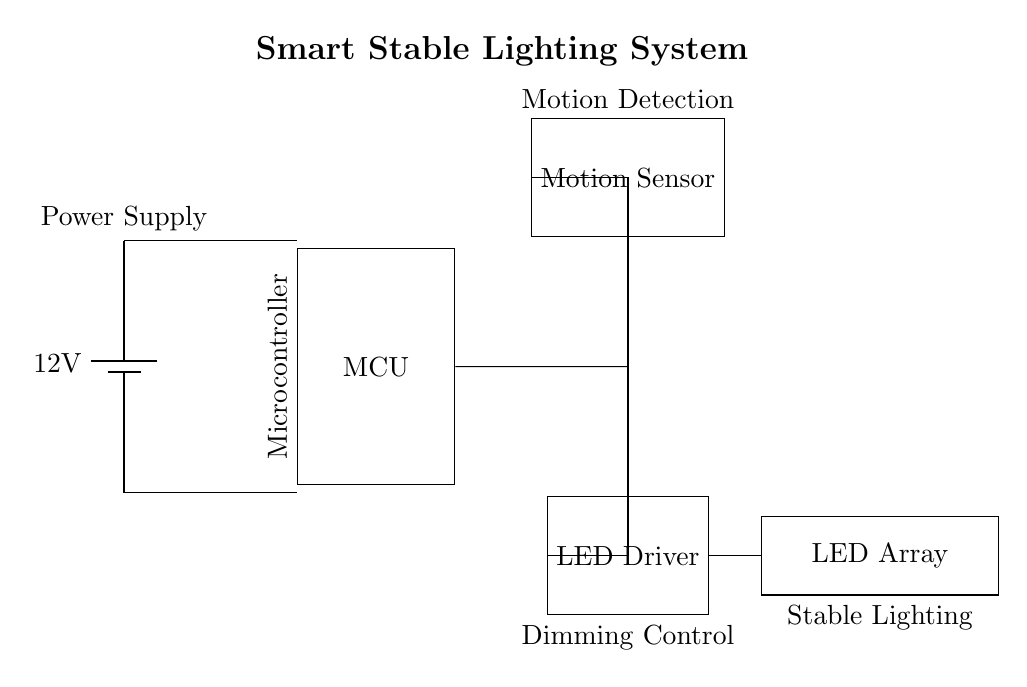What is the voltage of the power supply? The voltage is specified as 12 volts in the circuit. This is the potential difference provided by the battery.
Answer: 12 volts What component is used for motion detection? The component labeled as 'Motion Sensor' is responsible for detecting motion in the circuit diagram.
Answer: Motion Sensor What is the purpose of the LED driver in this circuit? The LED driver controls the brightness of the LED array, allowing for dimming capabilities. Its role is to provide the appropriate voltage and current to the LEDs.
Answer: Dimming control How many main components are shown in the circuit diagram? There are four main components: the power supply, the microcontroller, the motion sensor, and the LED driver. Counting these gives a total of four components.
Answer: Four Which component connects the motion sensor and the LED array? The LED Driver serves as the intermediary between the motion sensor control signals and the LED array, relaying the appropriate current to the lights.
Answer: LED Driver What does the microcontroller manage in this circuit? The microcontroller manages the overall system operation by receiving input from the motion sensor and controlling the LED driver based on detected motion.
Answer: System operation 